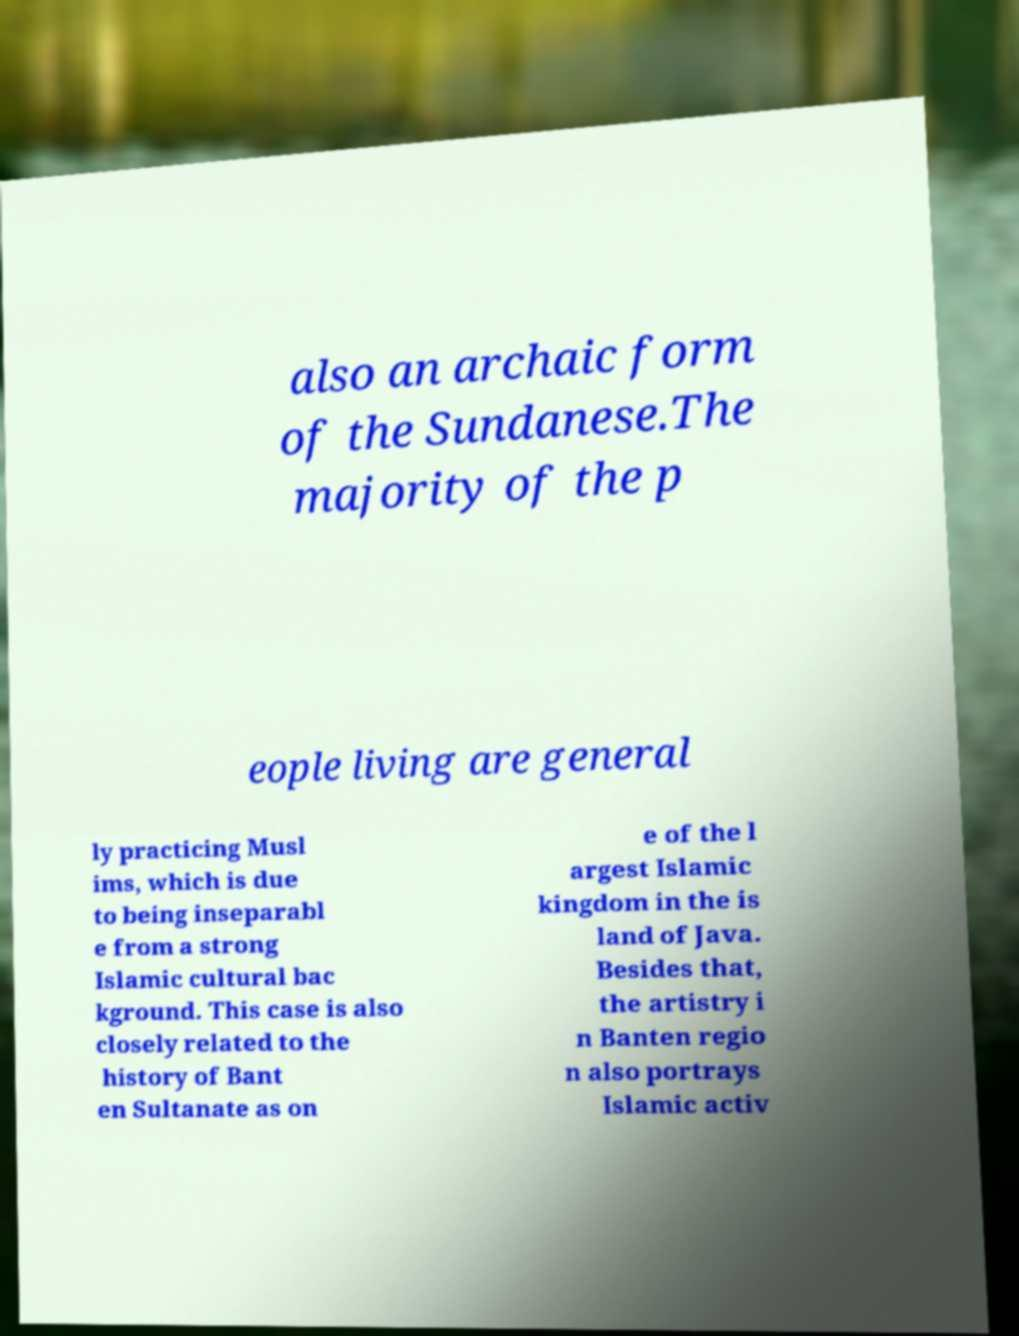Please identify and transcribe the text found in this image. also an archaic form of the Sundanese.The majority of the p eople living are general ly practicing Musl ims, which is due to being inseparabl e from a strong Islamic cultural bac kground. This case is also closely related to the history of Bant en Sultanate as on e of the l argest Islamic kingdom in the is land of Java. Besides that, the artistry i n Banten regio n also portrays Islamic activ 